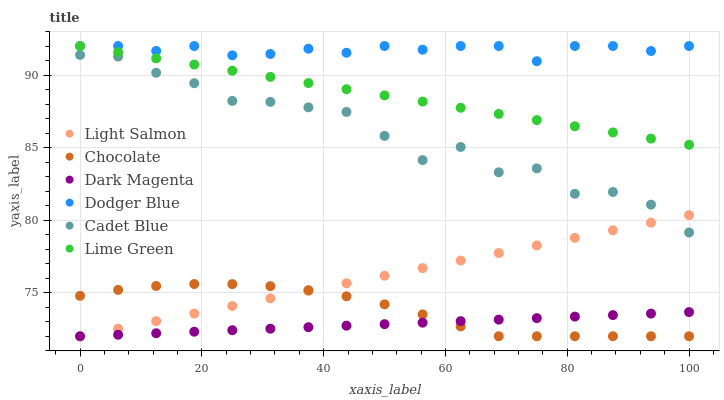Does Dark Magenta have the minimum area under the curve?
Answer yes or no. Yes. Does Dodger Blue have the maximum area under the curve?
Answer yes or no. Yes. Does Cadet Blue have the minimum area under the curve?
Answer yes or no. No. Does Cadet Blue have the maximum area under the curve?
Answer yes or no. No. Is Dark Magenta the smoothest?
Answer yes or no. Yes. Is Cadet Blue the roughest?
Answer yes or no. Yes. Is Cadet Blue the smoothest?
Answer yes or no. No. Is Dark Magenta the roughest?
Answer yes or no. No. Does Light Salmon have the lowest value?
Answer yes or no. Yes. Does Cadet Blue have the lowest value?
Answer yes or no. No. Does Lime Green have the highest value?
Answer yes or no. Yes. Does Cadet Blue have the highest value?
Answer yes or no. No. Is Light Salmon less than Lime Green?
Answer yes or no. Yes. Is Dodger Blue greater than Dark Magenta?
Answer yes or no. Yes. Does Light Salmon intersect Dark Magenta?
Answer yes or no. Yes. Is Light Salmon less than Dark Magenta?
Answer yes or no. No. Is Light Salmon greater than Dark Magenta?
Answer yes or no. No. Does Light Salmon intersect Lime Green?
Answer yes or no. No. 